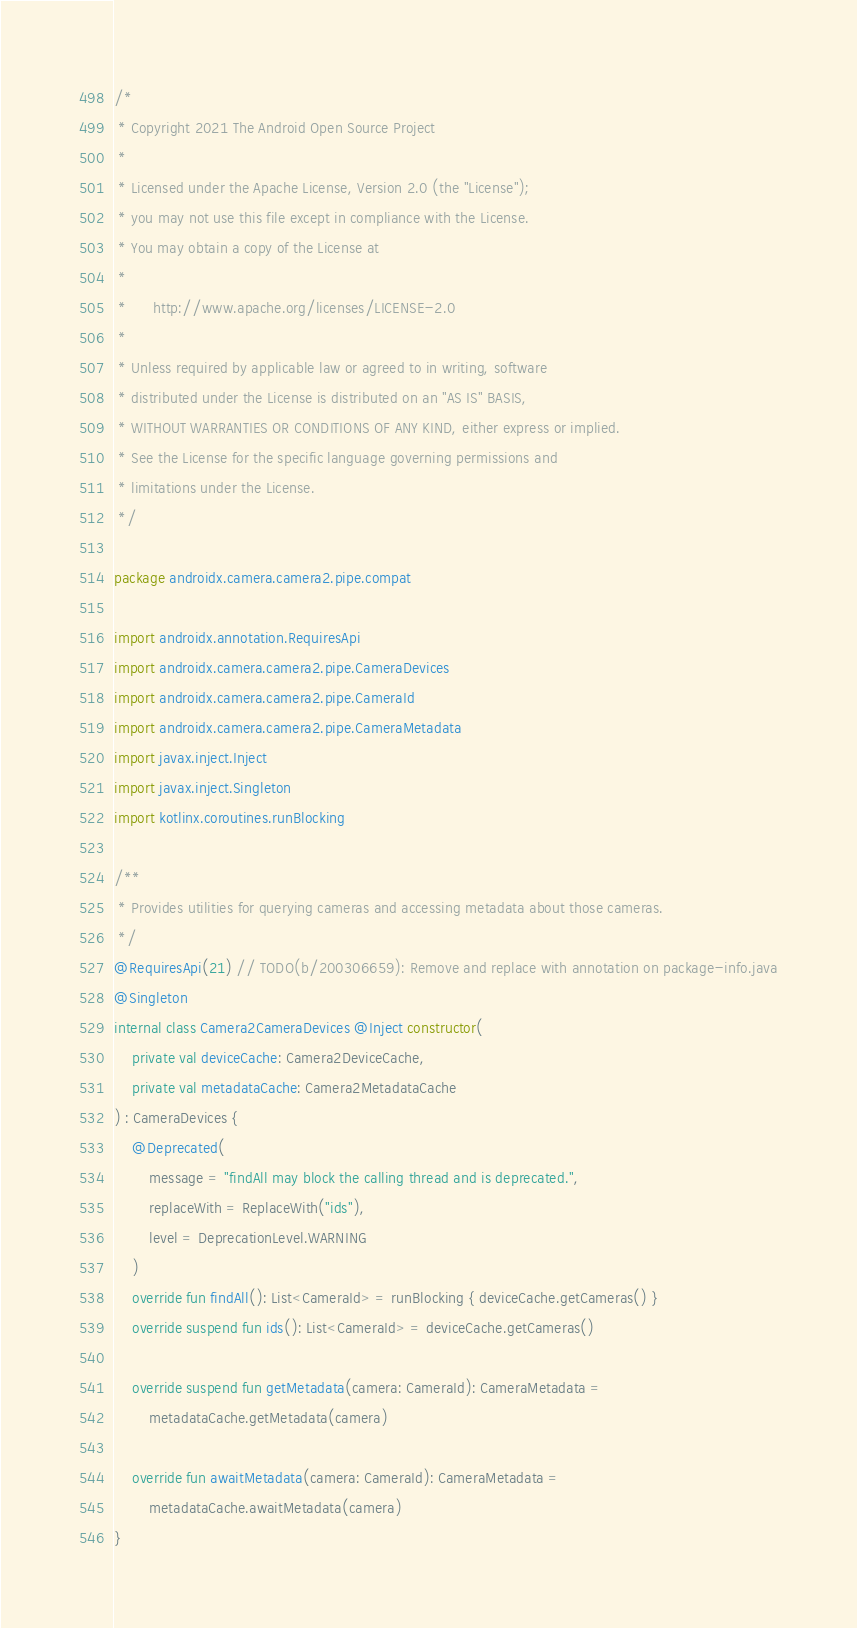Convert code to text. <code><loc_0><loc_0><loc_500><loc_500><_Kotlin_>/*
 * Copyright 2021 The Android Open Source Project
 *
 * Licensed under the Apache License, Version 2.0 (the "License");
 * you may not use this file except in compliance with the License.
 * You may obtain a copy of the License at
 *
 *      http://www.apache.org/licenses/LICENSE-2.0
 *
 * Unless required by applicable law or agreed to in writing, software
 * distributed under the License is distributed on an "AS IS" BASIS,
 * WITHOUT WARRANTIES OR CONDITIONS OF ANY KIND, either express or implied.
 * See the License for the specific language governing permissions and
 * limitations under the License.
 */

package androidx.camera.camera2.pipe.compat

import androidx.annotation.RequiresApi
import androidx.camera.camera2.pipe.CameraDevices
import androidx.camera.camera2.pipe.CameraId
import androidx.camera.camera2.pipe.CameraMetadata
import javax.inject.Inject
import javax.inject.Singleton
import kotlinx.coroutines.runBlocking

/**
 * Provides utilities for querying cameras and accessing metadata about those cameras.
 */
@RequiresApi(21) // TODO(b/200306659): Remove and replace with annotation on package-info.java
@Singleton
internal class Camera2CameraDevices @Inject constructor(
    private val deviceCache: Camera2DeviceCache,
    private val metadataCache: Camera2MetadataCache
) : CameraDevices {
    @Deprecated(
        message = "findAll may block the calling thread and is deprecated.",
        replaceWith = ReplaceWith("ids"),
        level = DeprecationLevel.WARNING
    )
    override fun findAll(): List<CameraId> = runBlocking { deviceCache.getCameras() }
    override suspend fun ids(): List<CameraId> = deviceCache.getCameras()

    override suspend fun getMetadata(camera: CameraId): CameraMetadata =
        metadataCache.getMetadata(camera)

    override fun awaitMetadata(camera: CameraId): CameraMetadata =
        metadataCache.awaitMetadata(camera)
}</code> 